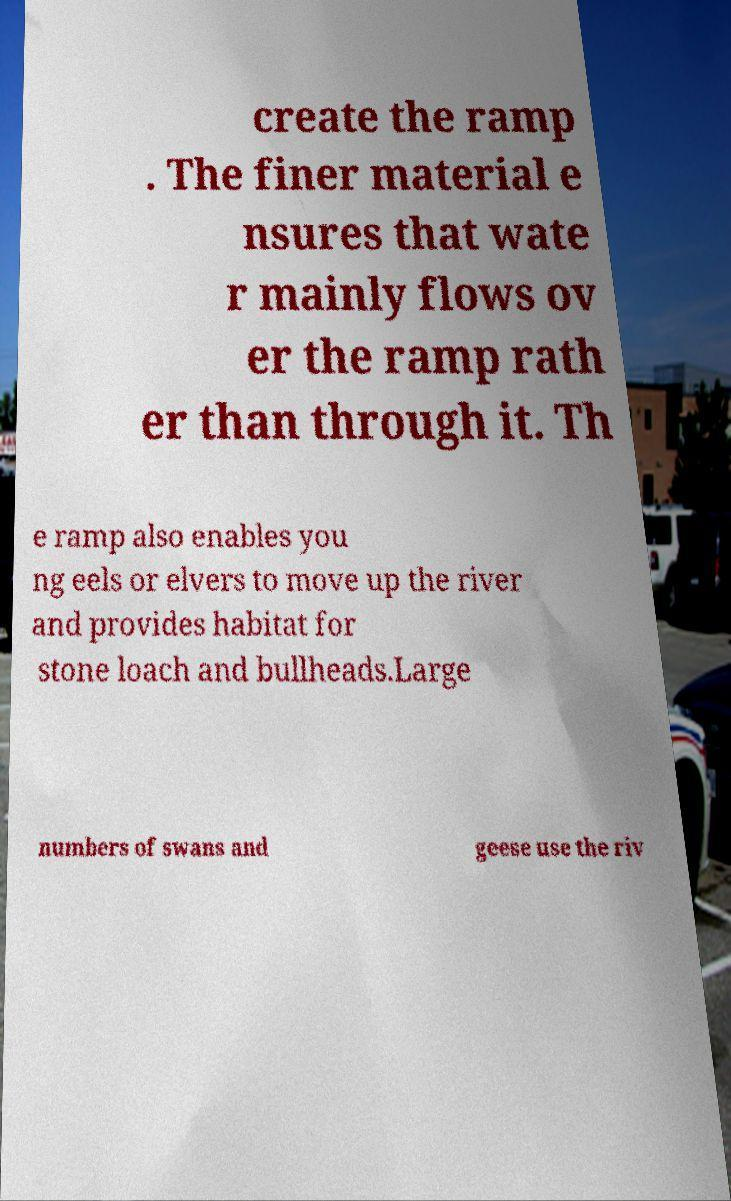Can you read and provide the text displayed in the image?This photo seems to have some interesting text. Can you extract and type it out for me? create the ramp . The finer material e nsures that wate r mainly flows ov er the ramp rath er than through it. Th e ramp also enables you ng eels or elvers to move up the river and provides habitat for stone loach and bullheads.Large numbers of swans and geese use the riv 